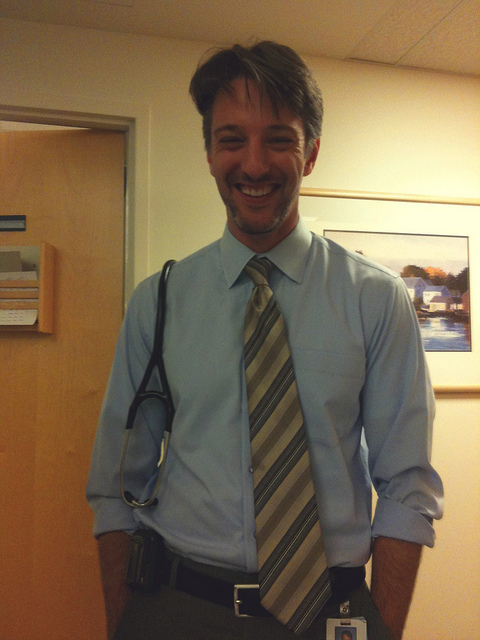<image>What number is on the left door? It is unknown what number is on the left door. Some answers suggest there is no number, while others suggest '0' or '23'. What number is on the left door? I am not sure what number is on the left door. It can be seen '0', 'no number' or 'unknown'. 